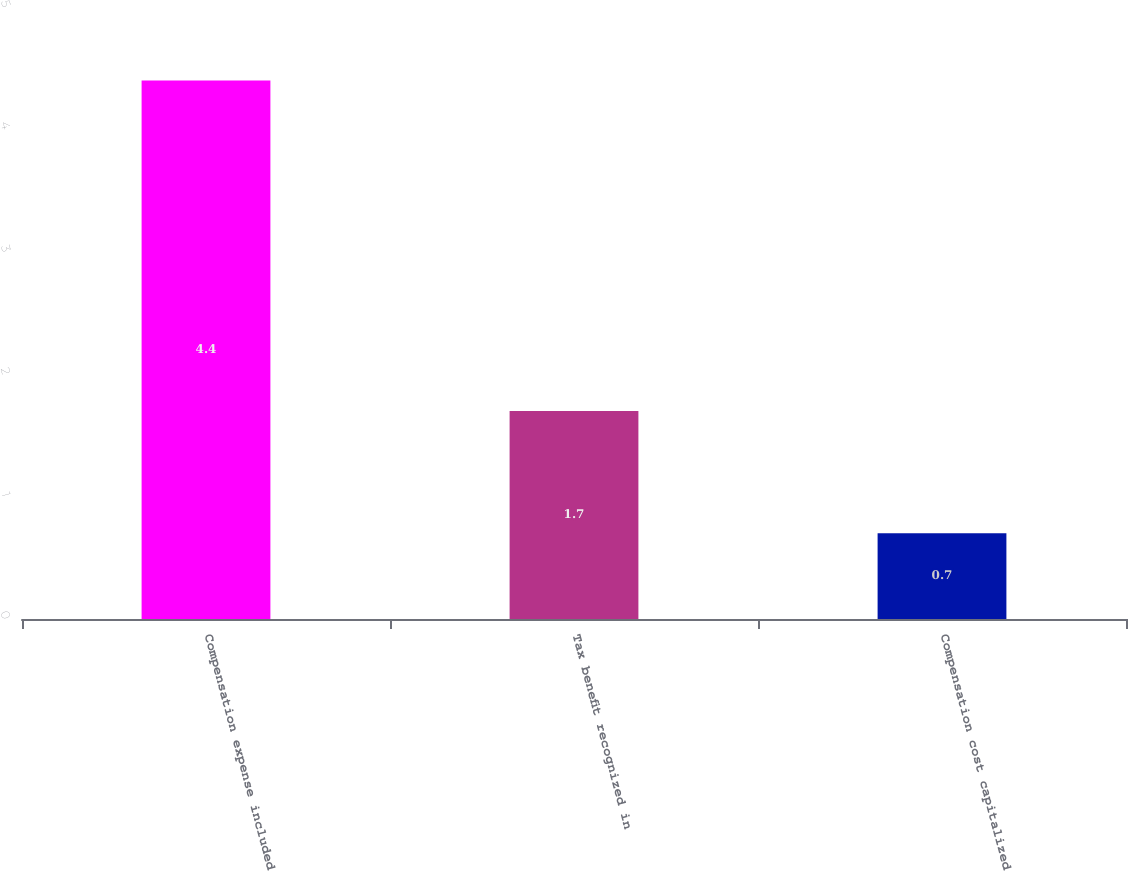Convert chart to OTSL. <chart><loc_0><loc_0><loc_500><loc_500><bar_chart><fcel>Compensation expense included<fcel>Tax benefit recognized in<fcel>Compensation cost capitalized<nl><fcel>4.4<fcel>1.7<fcel>0.7<nl></chart> 